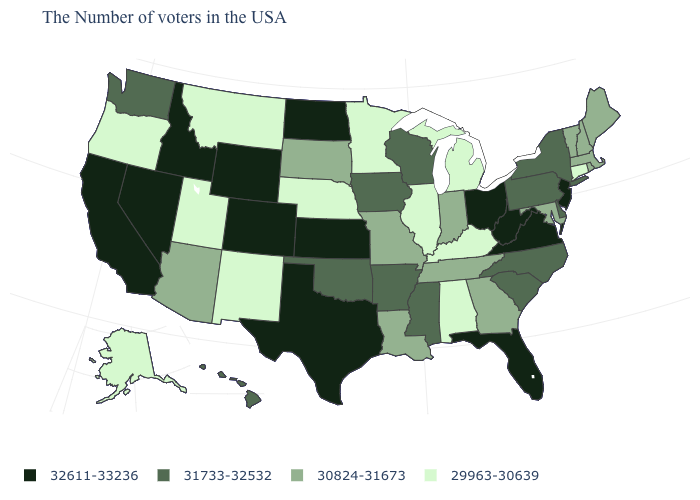What is the value of New Jersey?
Keep it brief. 32611-33236. Which states have the lowest value in the MidWest?
Quick response, please. Michigan, Illinois, Minnesota, Nebraska. Does Louisiana have a higher value than Utah?
Keep it brief. Yes. Is the legend a continuous bar?
Concise answer only. No. What is the value of Ohio?
Answer briefly. 32611-33236. Name the states that have a value in the range 30824-31673?
Short answer required. Maine, Massachusetts, Rhode Island, New Hampshire, Vermont, Maryland, Georgia, Indiana, Tennessee, Louisiana, Missouri, South Dakota, Arizona. What is the lowest value in states that border Delaware?
Concise answer only. 30824-31673. What is the value of Oklahoma?
Quick response, please. 31733-32532. What is the lowest value in the Northeast?
Answer briefly. 29963-30639. Name the states that have a value in the range 31733-32532?
Answer briefly. New York, Delaware, Pennsylvania, North Carolina, South Carolina, Wisconsin, Mississippi, Arkansas, Iowa, Oklahoma, Washington, Hawaii. Which states have the lowest value in the South?
Quick response, please. Kentucky, Alabama. Among the states that border South Dakota , does Minnesota have the highest value?
Short answer required. No. Does the map have missing data?
Be succinct. No. Among the states that border Maryland , which have the highest value?
Write a very short answer. Virginia, West Virginia. Which states hav the highest value in the West?
Be succinct. Wyoming, Colorado, Idaho, Nevada, California. 